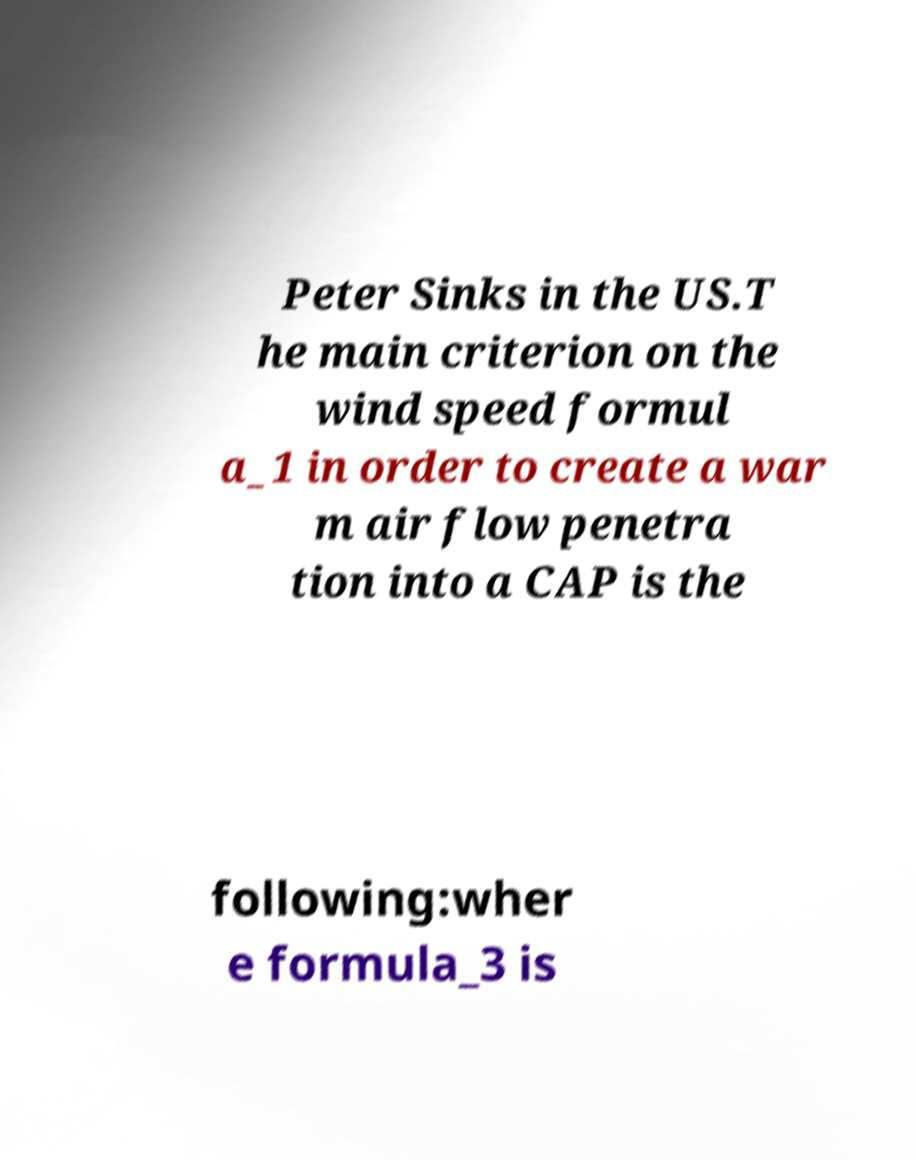Could you assist in decoding the text presented in this image and type it out clearly? Peter Sinks in the US.T he main criterion on the wind speed formul a_1 in order to create a war m air flow penetra tion into a CAP is the following:wher e formula_3 is 